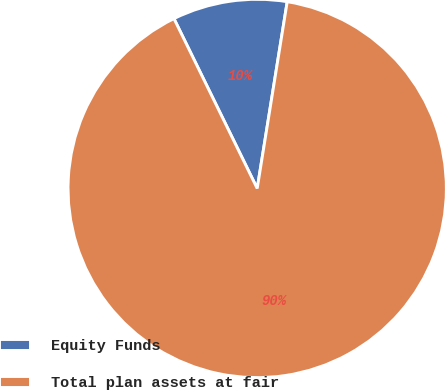Convert chart to OTSL. <chart><loc_0><loc_0><loc_500><loc_500><pie_chart><fcel>Equity Funds<fcel>Total plan assets at fair<nl><fcel>9.79%<fcel>90.21%<nl></chart> 